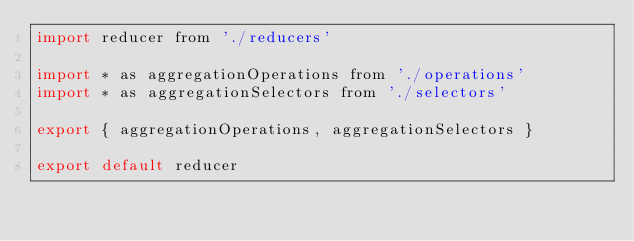<code> <loc_0><loc_0><loc_500><loc_500><_JavaScript_>import reducer from './reducers'

import * as aggregationOperations from './operations'
import * as aggregationSelectors from './selectors'

export { aggregationOperations, aggregationSelectors }

export default reducer
</code> 